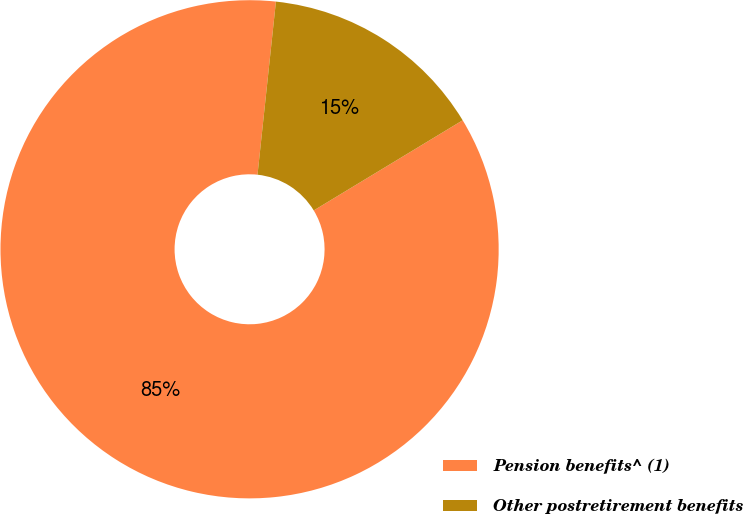Convert chart to OTSL. <chart><loc_0><loc_0><loc_500><loc_500><pie_chart><fcel>Pension benefits^ (1)<fcel>Other postretirement benefits<nl><fcel>85.35%<fcel>14.65%<nl></chart> 